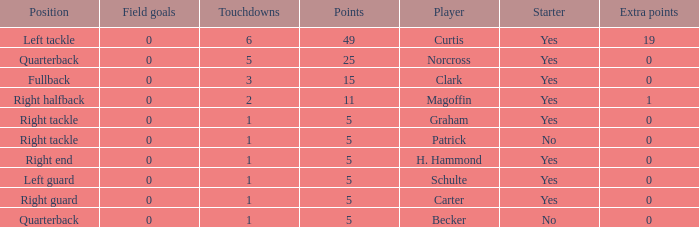Name the number of field goals for 19 extra points 1.0. 